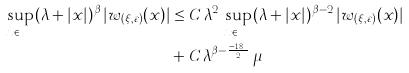Convert formula to latex. <formula><loc_0><loc_0><loc_500><loc_500>\sup _ { x \in \mathbb { R } ^ { n } } ( \lambda + | x | ) ^ { \beta } \, | w _ { ( \xi , \varepsilon ) } ( x ) | & \leq C \, \lambda ^ { 2 } \, \sup _ { x \in \mathbb { R } ^ { n } } ( \lambda + | x | ) ^ { \beta - 2 } \, | w _ { ( \xi , \varepsilon ) } ( x ) | \\ & + C \, \lambda ^ { \beta - \frac { n - 1 8 } { 2 } } \, \mu</formula> 